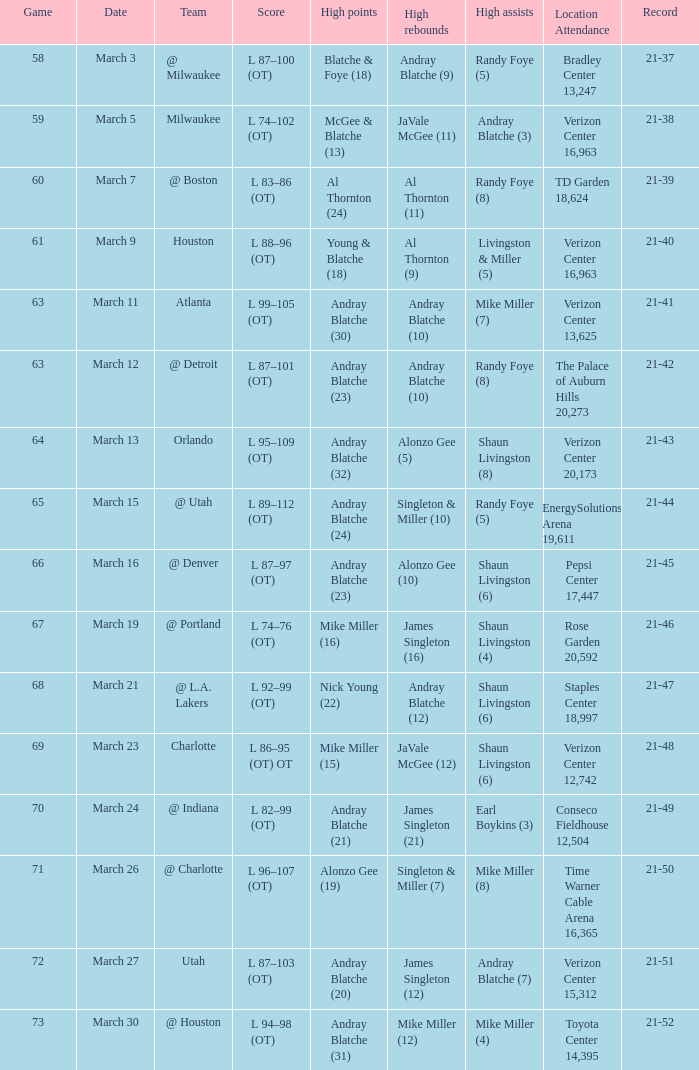Which date had a total of 18,624 attendees at td garden? March 7. 